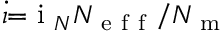<formula> <loc_0><loc_0><loc_500><loc_500>\dot { \iota } { = } i _ { N } N _ { e f f } / N _ { m }</formula> 